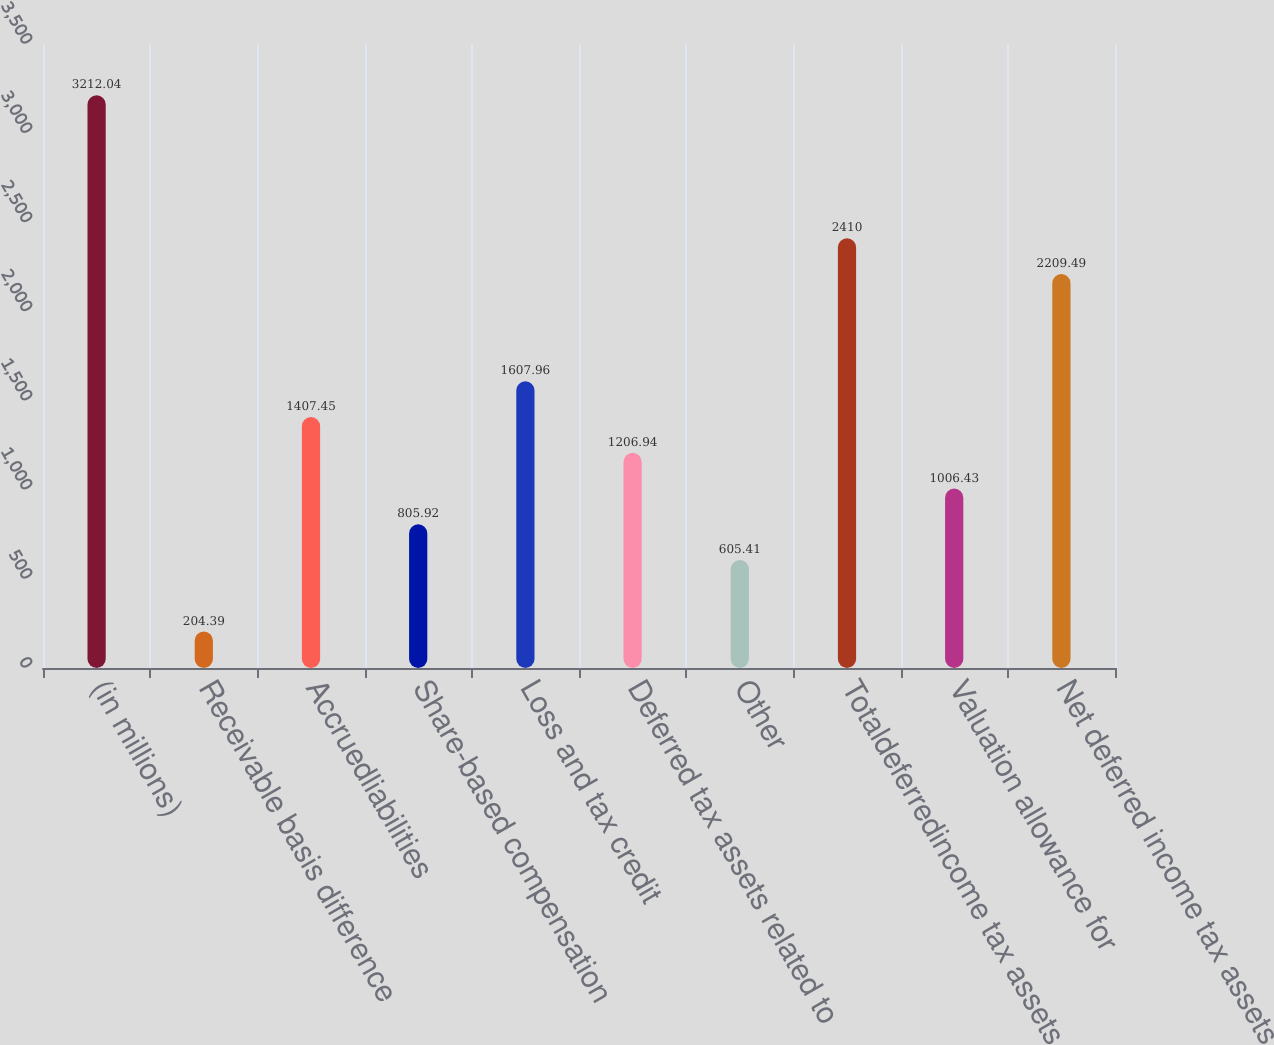Convert chart. <chart><loc_0><loc_0><loc_500><loc_500><bar_chart><fcel>(in millions)<fcel>Receivable basis difference<fcel>Accruedliabilities<fcel>Share-based compensation<fcel>Loss and tax credit<fcel>Deferred tax assets related to<fcel>Other<fcel>Totaldeferredincome tax assets<fcel>Valuation allowance for<fcel>Net deferred income tax assets<nl><fcel>3212.04<fcel>204.39<fcel>1407.45<fcel>805.92<fcel>1607.96<fcel>1206.94<fcel>605.41<fcel>2410<fcel>1006.43<fcel>2209.49<nl></chart> 